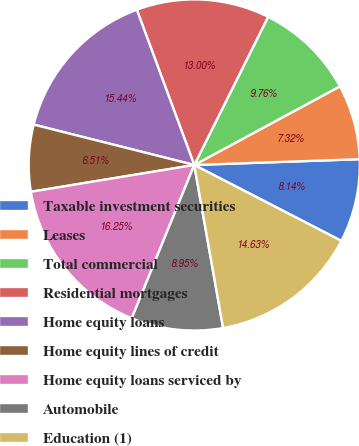Convert chart. <chart><loc_0><loc_0><loc_500><loc_500><pie_chart><fcel>Taxable investment securities<fcel>Leases<fcel>Total commercial<fcel>Residential mortgages<fcel>Home equity loans<fcel>Home equity lines of credit<fcel>Home equity loans serviced by<fcel>Automobile<fcel>Education (1)<nl><fcel>8.14%<fcel>7.32%<fcel>9.76%<fcel>13.0%<fcel>15.44%<fcel>6.51%<fcel>16.25%<fcel>8.95%<fcel>14.63%<nl></chart> 